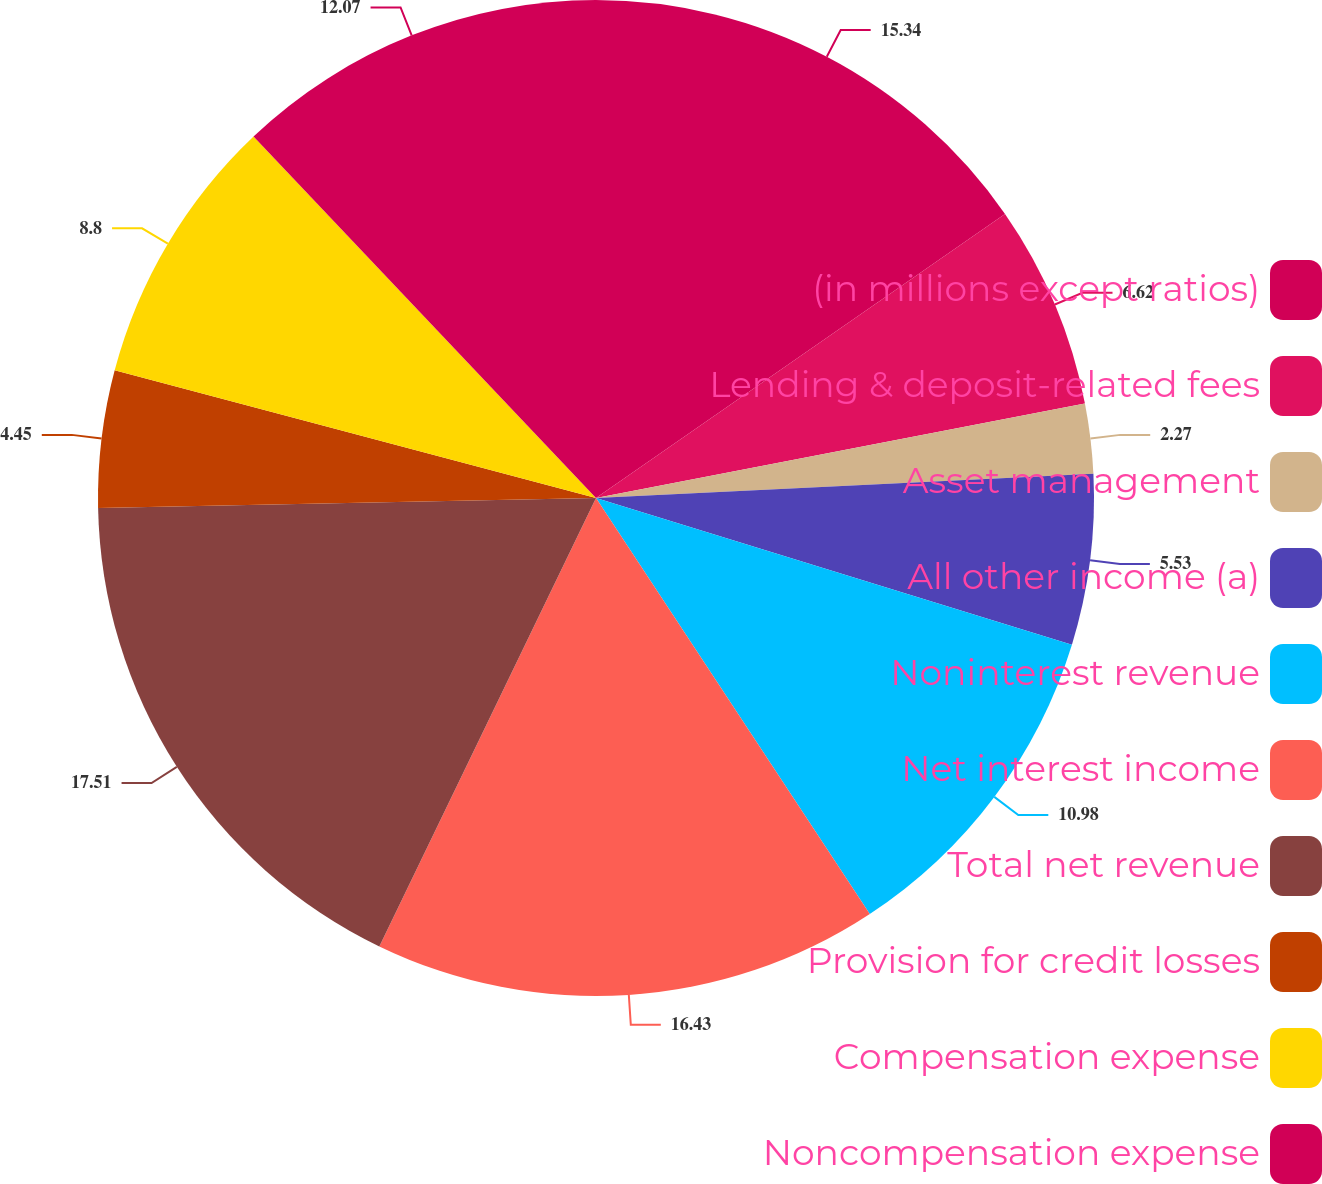Convert chart to OTSL. <chart><loc_0><loc_0><loc_500><loc_500><pie_chart><fcel>(in millions except ratios)<fcel>Lending & deposit-related fees<fcel>Asset management<fcel>All other income (a)<fcel>Noninterest revenue<fcel>Net interest income<fcel>Total net revenue<fcel>Provision for credit losses<fcel>Compensation expense<fcel>Noncompensation expense<nl><fcel>15.34%<fcel>6.62%<fcel>2.27%<fcel>5.53%<fcel>10.98%<fcel>16.43%<fcel>17.52%<fcel>4.45%<fcel>8.8%<fcel>12.07%<nl></chart> 